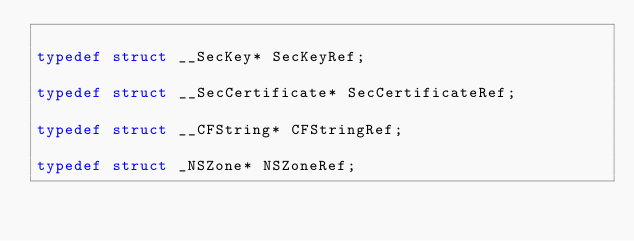Convert code to text. <code><loc_0><loc_0><loc_500><loc_500><_C_>
typedef struct __SecKey* SecKeyRef;

typedef struct __SecCertificate* SecCertificateRef;

typedef struct __CFString* CFStringRef;

typedef struct _NSZone* NSZoneRef;

</code> 